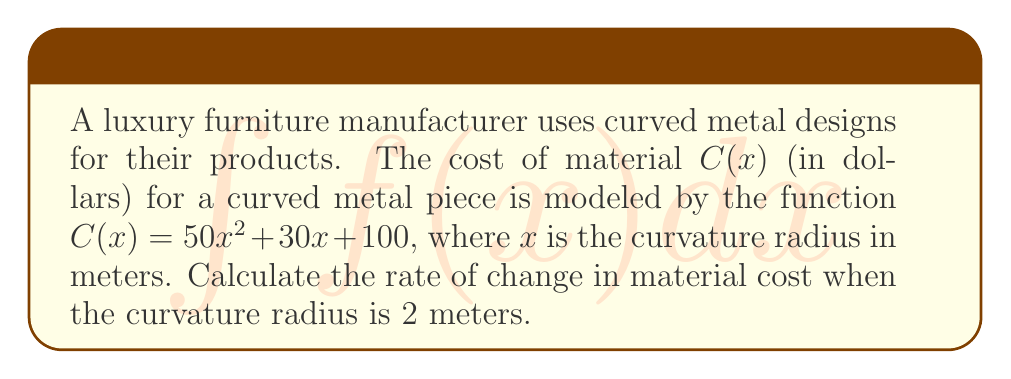Could you help me with this problem? To find the rate of change in material cost, we need to calculate the derivative of the cost function $C(x)$ and evaluate it at $x = 2$.

Step 1: Find the derivative of $C(x)$.
$$C(x) = 50x^2 + 30x + 100$$
$$\frac{d}{dx}C(x) = \frac{d}{dx}(50x^2 + 30x + 100)$$
$$C'(x) = 100x + 30$$

Step 2: Evaluate the derivative at $x = 2$.
$$C'(2) = 100(2) + 30$$
$$C'(2) = 200 + 30 = 230$$

The rate of change in material cost when the curvature radius is 2 meters is 230 dollars per meter.
Answer: $230$ dollars per meter 